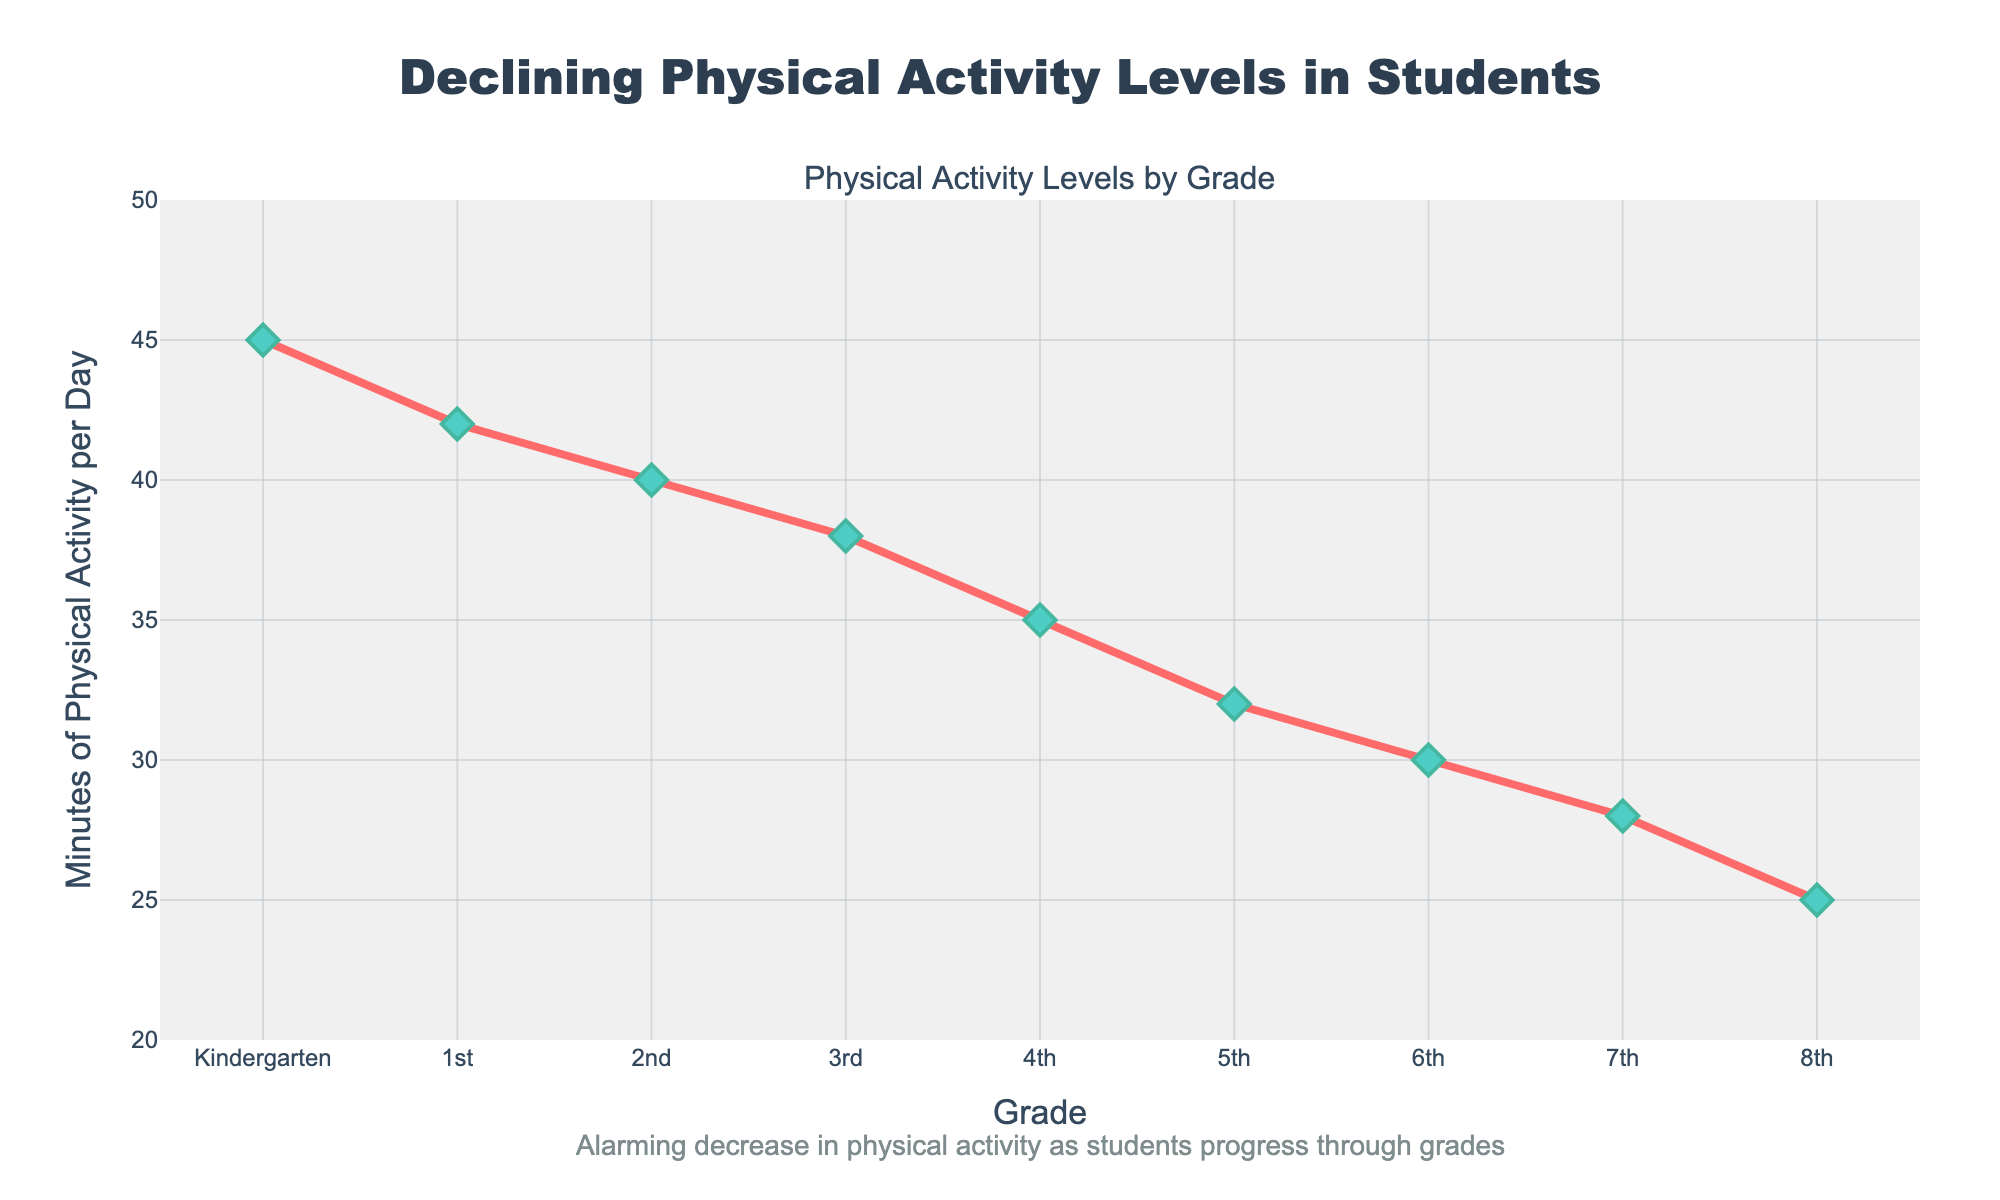What is the overall trend of physical activity levels as students progress through grades? Observe that the line on the chart shows a clear downward slope from Kindergarten to 8th Grade, indicating a decline in the number of minutes of physical activity per day.
Answer: Decreasing Which grade has the lowest amount of physical activity per day? Identify the lowest point on the line chart, which occurs at 8th Grade, indicating the least amount of physical activity per day.
Answer: 8th Grade How many more minutes of physical activity do Kindergarten students have compared to 8th Grade students? Note that Kindergarten students have 45 minutes per day, whereas 8th Grade students have 25 minutes per day. The difference is 45 - 25.
Answer: 20 minutes Which grades have fewer than 35 minutes of physical activity per day? Check the y-axis on the chart and identify the grades where the line is below 35 minutes, which are 4th Grade through 8th Grade.
Answer: 4th, 5th, 6th, 7th, 8th What is the average number of minutes of physical activity per day across all grades? Sum the minutes per day for all grades and divide by the number of grades: (45 + 42 + 40 + 38 + 35 + 32 + 30 + 28 + 25) / 9.
Answer: 35 minutes How does the physical activity level of 3rd Grade students compare to that of 5th Grade students? Locate the points on the chart for 3rd and 5th Grades. 3rd Grade has 38 minutes and 5th Grade has 32 minutes. Therefore, 3rd Grade students have more physical activity per day.
Answer: 3rd Grade > 5th Grade What can be inferred about the physical activity levels between 1st and 7th Grades? Observe the slope between the points for 1st and 7th Grades, showing a decline from 42 to 28 minutes per day. This indicates a consistent decrease in physical activity levels as students progress from 1st to 7th Grade.
Answer: Decreasing trend By how many minutes does physical activity decrease on average per grade level? The difference between the highest and lowest activity levels is 45 - 25 = 20 minutes over 8 grade levels. The average decrease per grade is 20 / 8.
Answer: 2.5 minutes per day Which grade shows the most significant drop in physical activity compared to its previous grade? Note the differences between consecutive grades: (45-42), (42-40), (40-38), and so on. The largest drop is between 4th Grade and 3rd Grade, a 3-minute decrease.
Answer: 3rd to 4th Grade What is the annotation saying about the overall trend? Read the annotation on the figure, which highlights a continuous decrease in physical activity levels as students progress through grades, describing it as 'alarming.'
Answer: Decreasing activity 